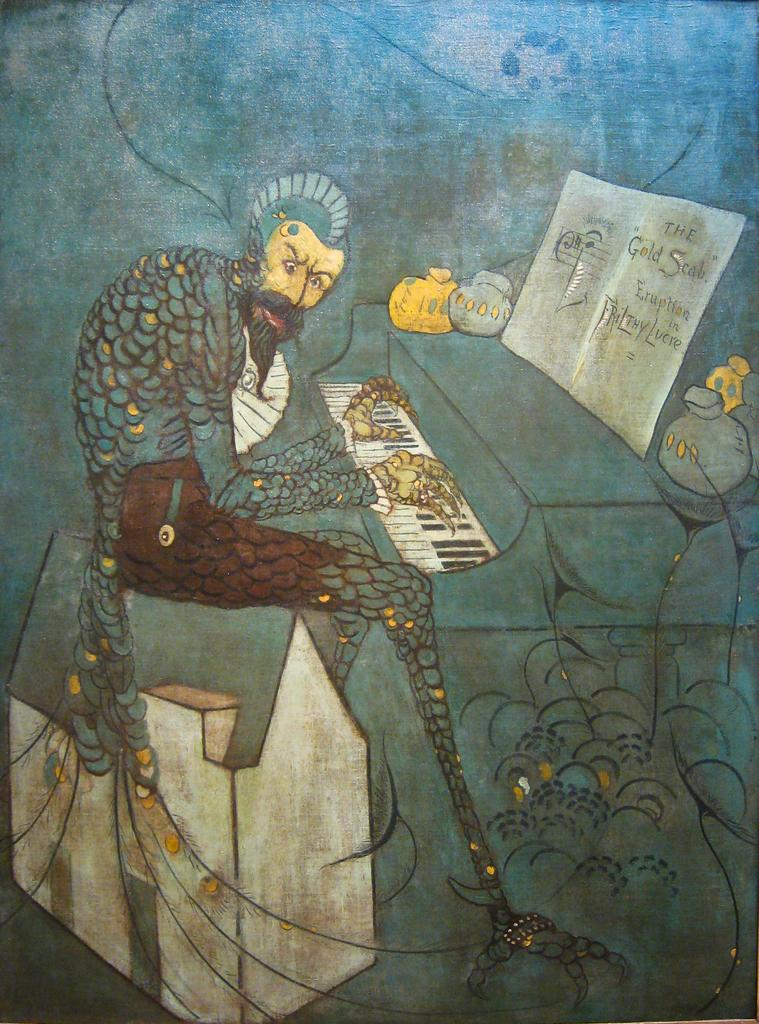What type of artwork is depicted in the image? The image is a painting. What is the main subject of the painting? There is a person playing a keyboard in the center of the image. What can be seen on the right side of the painting? There are objects on the right side of the image, including a book. What type of feeling does the rain evoke in the painting? There is no rain present in the painting, so it cannot evoke any feelings related to rain. 